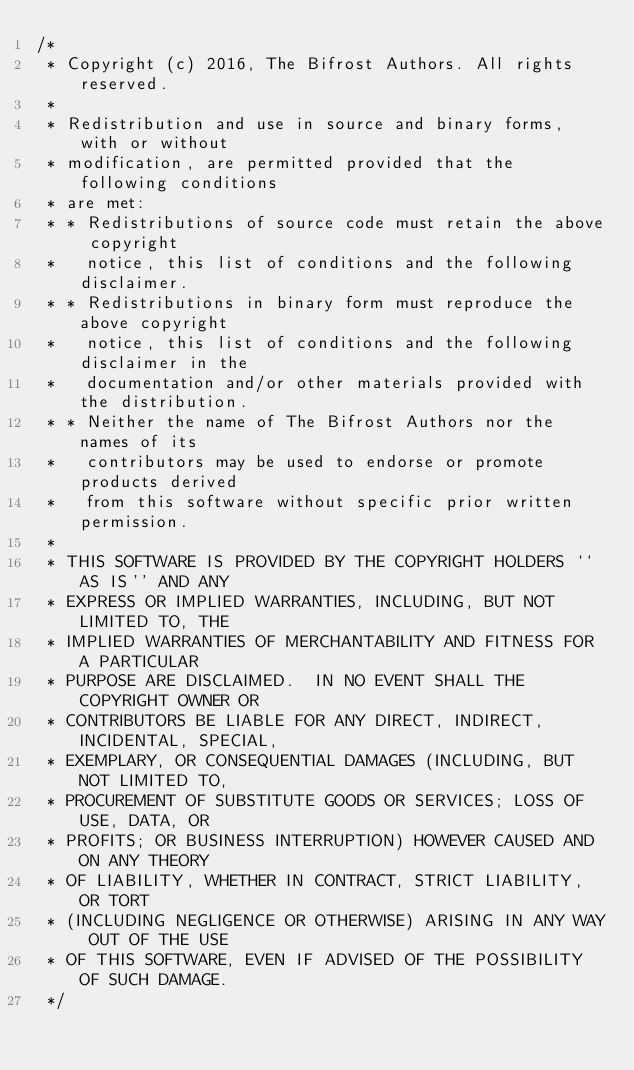<code> <loc_0><loc_0><loc_500><loc_500><_Cuda_>/*
 * Copyright (c) 2016, The Bifrost Authors. All rights reserved.
 *
 * Redistribution and use in source and binary forms, with or without
 * modification, are permitted provided that the following conditions
 * are met:
 * * Redistributions of source code must retain the above copyright
 *   notice, this list of conditions and the following disclaimer.
 * * Redistributions in binary form must reproduce the above copyright
 *   notice, this list of conditions and the following disclaimer in the
 *   documentation and/or other materials provided with the distribution.
 * * Neither the name of The Bifrost Authors nor the names of its
 *   contributors may be used to endorse or promote products derived
 *   from this software without specific prior written permission.
 *
 * THIS SOFTWARE IS PROVIDED BY THE COPYRIGHT HOLDERS ``AS IS'' AND ANY
 * EXPRESS OR IMPLIED WARRANTIES, INCLUDING, BUT NOT LIMITED TO, THE
 * IMPLIED WARRANTIES OF MERCHANTABILITY AND FITNESS FOR A PARTICULAR
 * PURPOSE ARE DISCLAIMED.  IN NO EVENT SHALL THE COPYRIGHT OWNER OR
 * CONTRIBUTORS BE LIABLE FOR ANY DIRECT, INDIRECT, INCIDENTAL, SPECIAL,
 * EXEMPLARY, OR CONSEQUENTIAL DAMAGES (INCLUDING, BUT NOT LIMITED TO,
 * PROCUREMENT OF SUBSTITUTE GOODS OR SERVICES; LOSS OF USE, DATA, OR
 * PROFITS; OR BUSINESS INTERRUPTION) HOWEVER CAUSED AND ON ANY THEORY
 * OF LIABILITY, WHETHER IN CONTRACT, STRICT LIABILITY, OR TORT
 * (INCLUDING NEGLIGENCE OR OTHERWISE) ARISING IN ANY WAY OUT OF THE USE
 * OF THIS SOFTWARE, EVEN IF ADVISED OF THE POSSIBILITY OF SUCH DAMAGE.
 */
</code> 